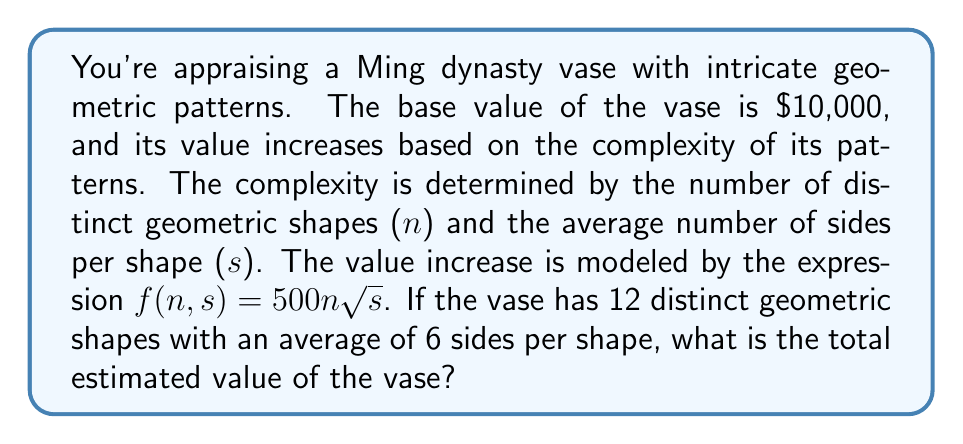Solve this math problem. Let's approach this step-by-step:

1) We're given that the base value of the vase is $10,000.

2) The value increase is modeled by the function:
   $$f(n,s) = 500n\sqrt{s}$$
   where n is the number of distinct geometric shapes and s is the average number of sides per shape.

3) We're told that:
   $n = 12$ (distinct geometric shapes)
   $s = 6$ (average sides per shape)

4) Let's calculate the value increase:
   $$f(12,6) = 500 \cdot 12 \cdot \sqrt{6}$$

5) Simplify:
   $$f(12,6) = 6000 \cdot \sqrt{6}$$
   $$f(12,6) = 6000 \cdot \sqrt{6} \approx 14,696.94$$

6) The total estimated value is the base value plus the increase:
   $$\text{Total Value} = 10,000 + 14,696.94 = 24,696.94$$

7) Rounding to the nearest dollar (as is common in appraisals):
   $$\text{Total Value} \approx 24,697$$
Answer: $24,697 